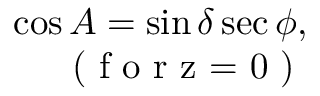<formula> <loc_0><loc_0><loc_500><loc_500>\begin{array} { r } { \cos A = \sin \delta \sec \phi , } \\ { ( f o r z = 0 ) } \end{array}</formula> 